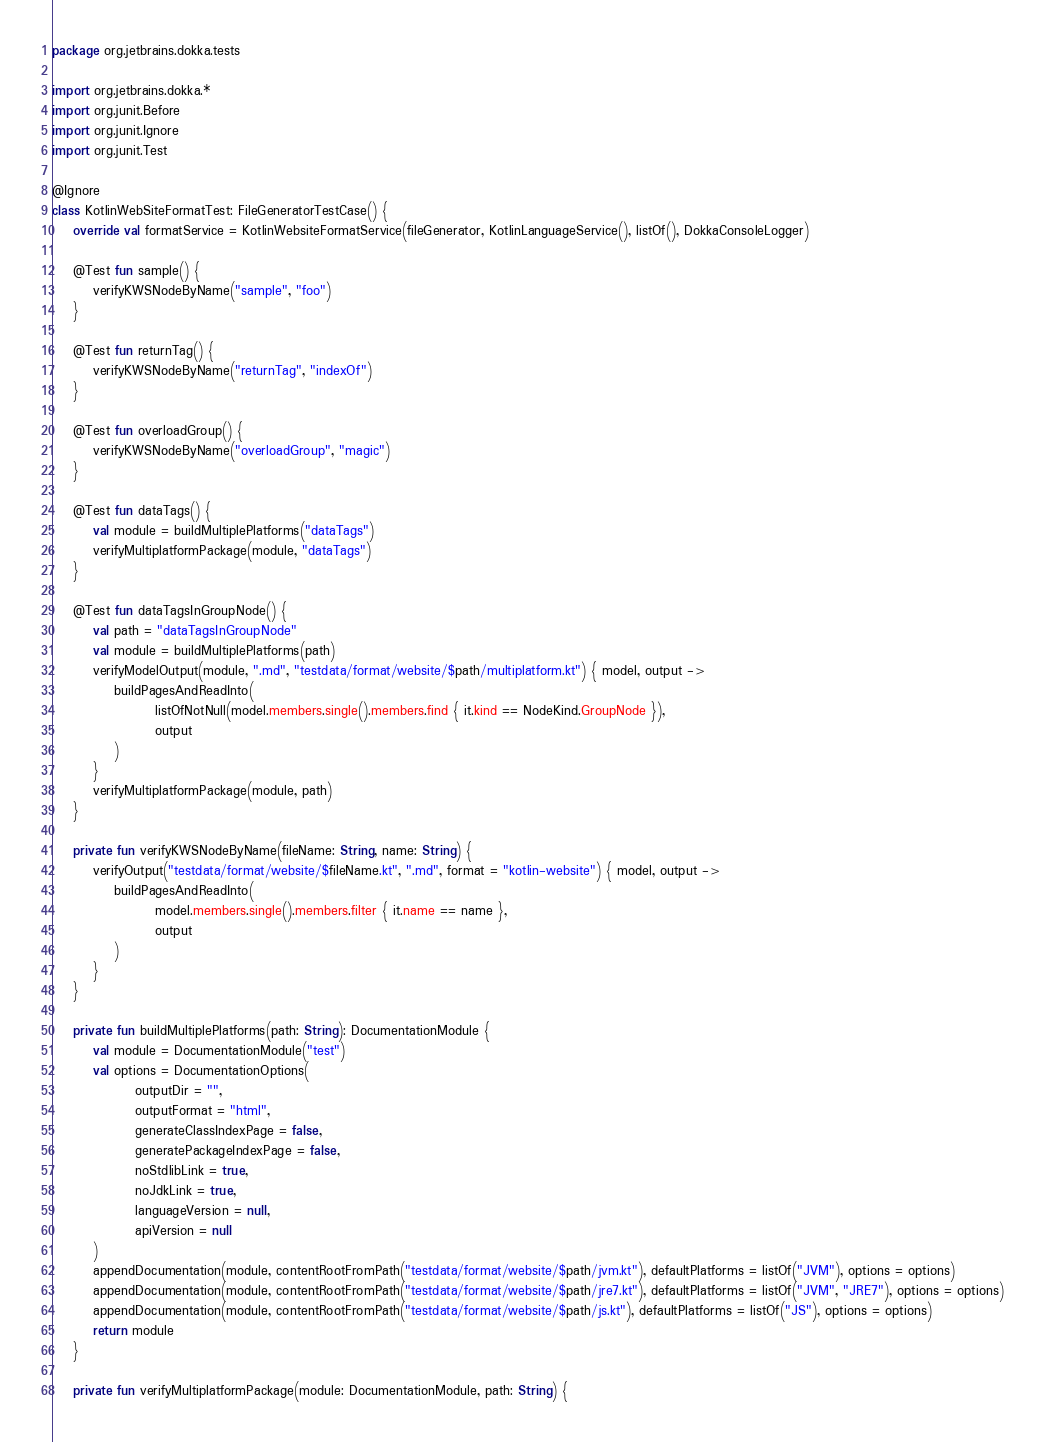<code> <loc_0><loc_0><loc_500><loc_500><_Kotlin_>package org.jetbrains.dokka.tests

import org.jetbrains.dokka.*
import org.junit.Before
import org.junit.Ignore
import org.junit.Test

@Ignore
class KotlinWebSiteFormatTest: FileGeneratorTestCase() {
    override val formatService = KotlinWebsiteFormatService(fileGenerator, KotlinLanguageService(), listOf(), DokkaConsoleLogger)

    @Test fun sample() {
        verifyKWSNodeByName("sample", "foo")
    }

    @Test fun returnTag() {
        verifyKWSNodeByName("returnTag", "indexOf")
    }

    @Test fun overloadGroup() {
        verifyKWSNodeByName("overloadGroup", "magic")
    }

    @Test fun dataTags() {
        val module = buildMultiplePlatforms("dataTags")
        verifyMultiplatformPackage(module, "dataTags")
    }

    @Test fun dataTagsInGroupNode() {
        val path = "dataTagsInGroupNode"
        val module = buildMultiplePlatforms(path)
        verifyModelOutput(module, ".md", "testdata/format/website/$path/multiplatform.kt") { model, output ->
            buildPagesAndReadInto(
                    listOfNotNull(model.members.single().members.find { it.kind == NodeKind.GroupNode }),
                    output
            )
        }
        verifyMultiplatformPackage(module, path)
    }

    private fun verifyKWSNodeByName(fileName: String, name: String) {
        verifyOutput("testdata/format/website/$fileName.kt", ".md", format = "kotlin-website") { model, output ->
            buildPagesAndReadInto(
                    model.members.single().members.filter { it.name == name },
                    output
            )
        }
    }

    private fun buildMultiplePlatforms(path: String): DocumentationModule {
        val module = DocumentationModule("test")
        val options = DocumentationOptions(
                outputDir = "",
                outputFormat = "html",
                generateClassIndexPage = false,
                generatePackageIndexPage = false,
                noStdlibLink = true,
                noJdkLink = true,
                languageVersion = null,
                apiVersion = null
        )
        appendDocumentation(module, contentRootFromPath("testdata/format/website/$path/jvm.kt"), defaultPlatforms = listOf("JVM"), options = options)
        appendDocumentation(module, contentRootFromPath("testdata/format/website/$path/jre7.kt"), defaultPlatforms = listOf("JVM", "JRE7"), options = options)
        appendDocumentation(module, contentRootFromPath("testdata/format/website/$path/js.kt"), defaultPlatforms = listOf("JS"), options = options)
        return module
    }

    private fun verifyMultiplatformPackage(module: DocumentationModule, path: String) {</code> 